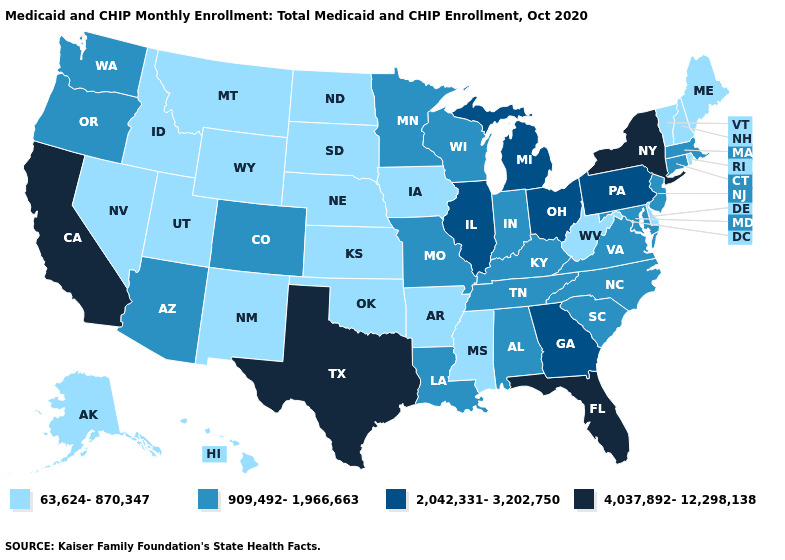Does Maine have a higher value than Illinois?
Be succinct. No. Which states have the lowest value in the USA?
Short answer required. Alaska, Arkansas, Delaware, Hawaii, Idaho, Iowa, Kansas, Maine, Mississippi, Montana, Nebraska, Nevada, New Hampshire, New Mexico, North Dakota, Oklahoma, Rhode Island, South Dakota, Utah, Vermont, West Virginia, Wyoming. Name the states that have a value in the range 909,492-1,966,663?
Answer briefly. Alabama, Arizona, Colorado, Connecticut, Indiana, Kentucky, Louisiana, Maryland, Massachusetts, Minnesota, Missouri, New Jersey, North Carolina, Oregon, South Carolina, Tennessee, Virginia, Washington, Wisconsin. What is the value of North Carolina?
Short answer required. 909,492-1,966,663. Which states have the lowest value in the MidWest?
Answer briefly. Iowa, Kansas, Nebraska, North Dakota, South Dakota. What is the lowest value in states that border Georgia?
Quick response, please. 909,492-1,966,663. Name the states that have a value in the range 909,492-1,966,663?
Concise answer only. Alabama, Arizona, Colorado, Connecticut, Indiana, Kentucky, Louisiana, Maryland, Massachusetts, Minnesota, Missouri, New Jersey, North Carolina, Oregon, South Carolina, Tennessee, Virginia, Washington, Wisconsin. What is the value of New Hampshire?
Keep it brief. 63,624-870,347. Does Colorado have a higher value than Utah?
Give a very brief answer. Yes. Among the states that border Arkansas , does Tennessee have the lowest value?
Keep it brief. No. Does New Mexico have the same value as Mississippi?
Be succinct. Yes. Does Utah have the highest value in the USA?
Give a very brief answer. No. What is the lowest value in the South?
Concise answer only. 63,624-870,347. Does Florida have the highest value in the USA?
Keep it brief. Yes. What is the lowest value in the USA?
Be succinct. 63,624-870,347. 